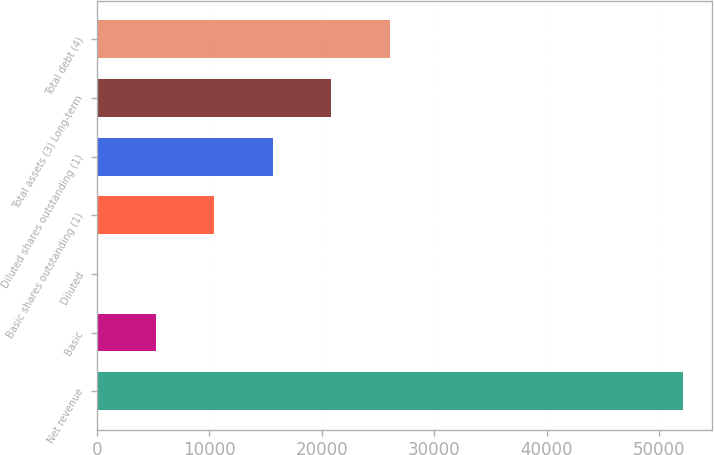Convert chart. <chart><loc_0><loc_0><loc_500><loc_500><bar_chart><fcel>Net revenue<fcel>Basic<fcel>Diluted<fcel>Basic shares outstanding (1)<fcel>Diluted shares outstanding (1)<fcel>Total assets (3) Long-term<fcel>Total debt (4)<nl><fcel>52107<fcel>5211.91<fcel>1.34<fcel>10422.5<fcel>15633<fcel>20843.6<fcel>26054.2<nl></chart> 